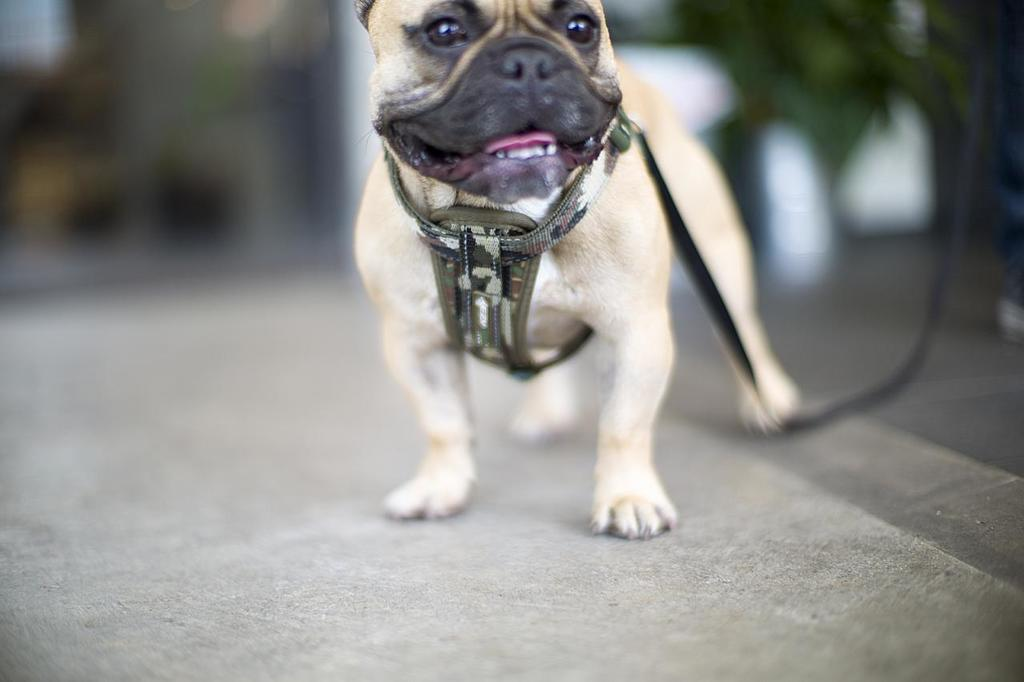What type of animal is present in the image? There is a dog in the image. How is the dog secured in the image? The dog is tied with a belt. What can be seen at the bottom of the image? There is a road at the bottom of the image. Can you describe the background of the image? The background of the image is blurred. What type of map is the dog using to find its way in the image? There is no map present in the image, and the dog is not shown navigating or finding its way. 